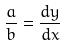Convert formula to latex. <formula><loc_0><loc_0><loc_500><loc_500>\frac { a } { b } = \frac { d y } { d x }</formula> 